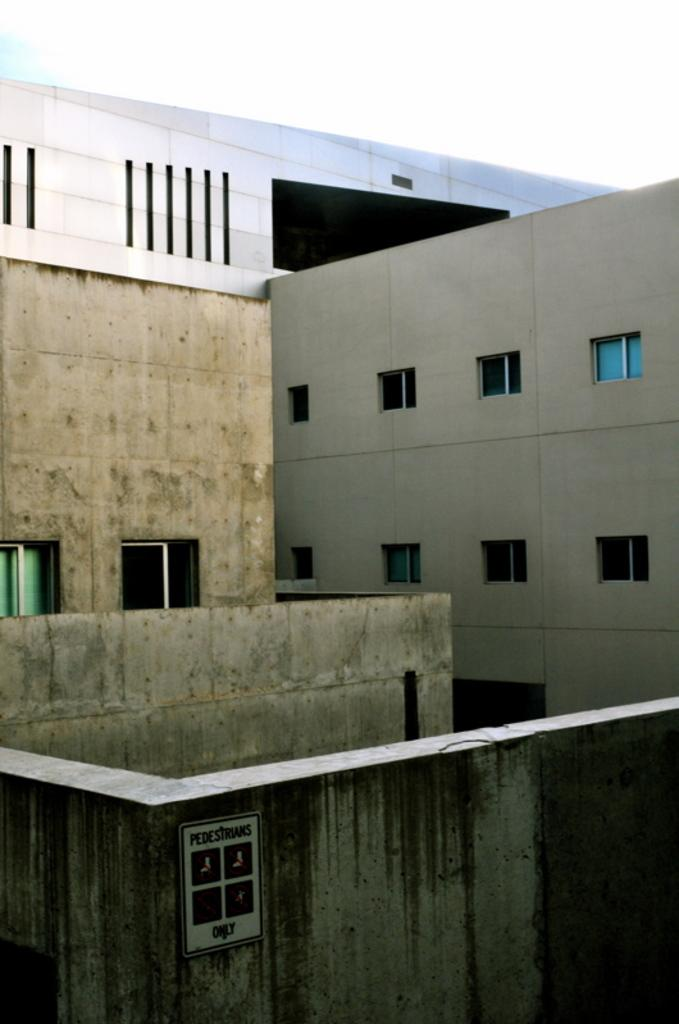What type of structures can be seen in the image? There are buildings in the image. What feature is present on the buildings? There are glass windows on the buildings. What is located at the bottom of the image? There is a board at the bottom of the image. What can be found on the board? There is text on the board. What is visible at the top of the image? The sky is visible at the top of the image. What type of bread is being used as bait for the fish in the image? There is no bread or fish present in the image; it features buildings, glass windows, a board with text, and a visible sky. 